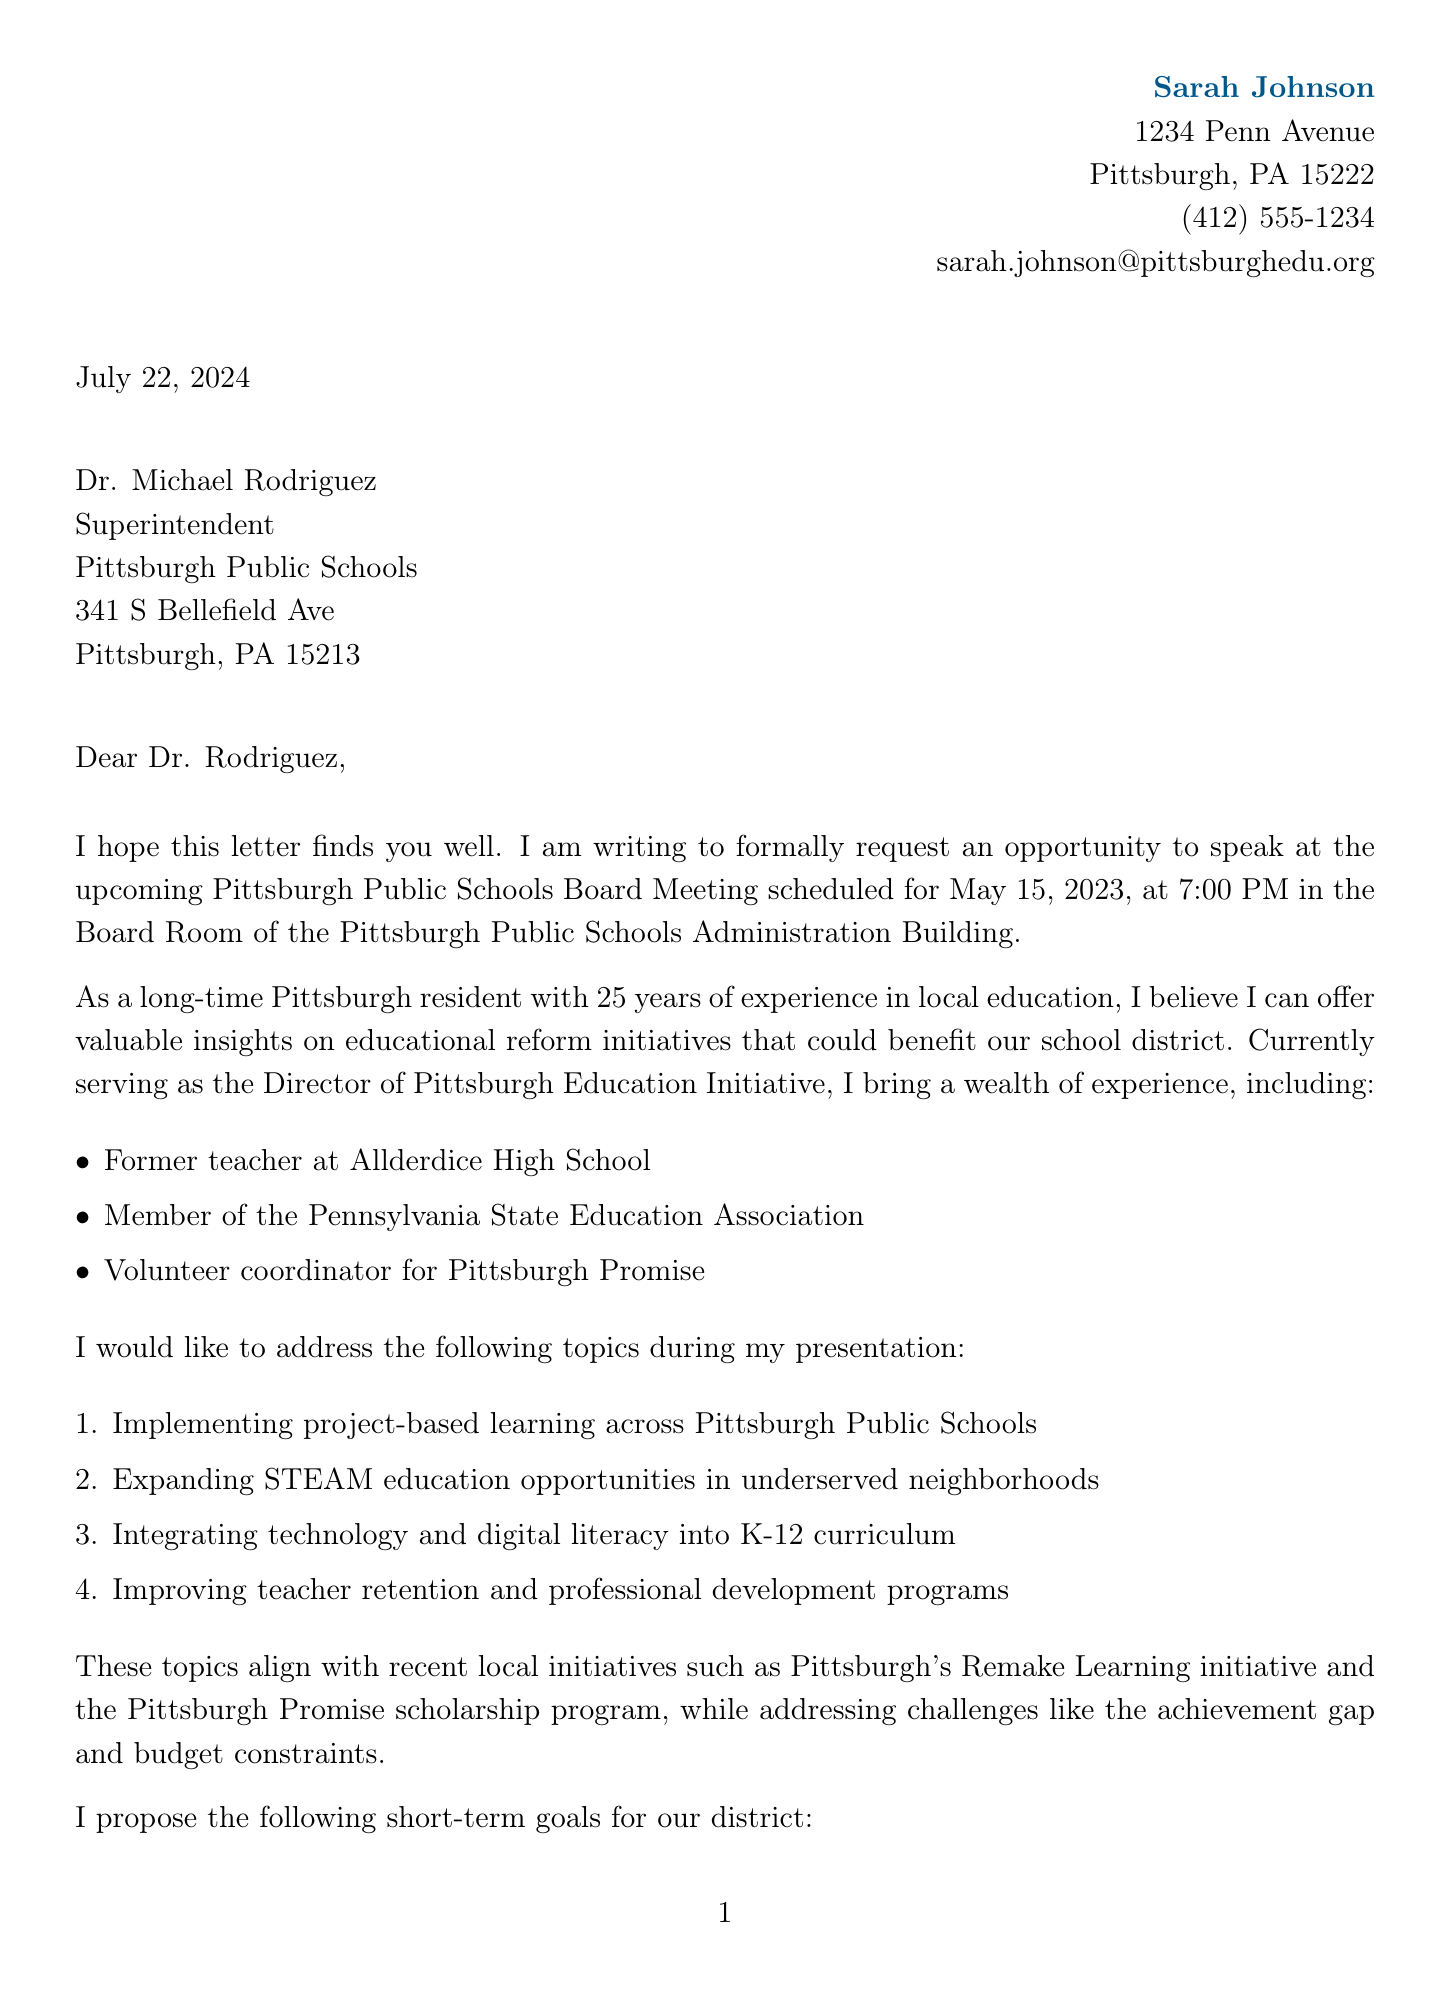What is the sender's name? The sender's name is stated at the beginning of the document.
Answer: Sarah Johnson What is the address of the recipient? The recipient's address is located within the recipient information section.
Answer: 341 S Bellefield Ave, Pittsburgh, PA 15213 What is the date of the board meeting? The date is specified in the event details section of the document.
Answer: May 15, 2023 What is one of the proposed topics for presentation? The proposed topics are listed in a numbered format within the document.
Answer: Implementing project-based learning across Pittsburgh Public Schools What is the current role of the sender? The sender's current position is mentioned in the speaker qualifications section.
Answer: Director of Pittsburgh Education Initiative What is the long-term vision mentioned in the document? The long-term vision is outlined as a set of goals related to education reform in the reform initiatives section.
Answer: Achieve 100% high school graduation rate by 2030 Who is the letter addressed to? The recipient's title and name are clearly stated in the salutation.
Answer: Dr. Michael Rodriguez What are the short-term goals mentioned? Short-term goals are listed under reform initiatives, detailing specific actions for education improvement.
Answer: Implement a district-wide mentoring program for new teachers What is the closing remark from the sender? The closing remarks summarize the sender's gratitude and commitment, found at the end of the letter.
Answer: Thank you for considering my request to speak at the upcoming board meeting 